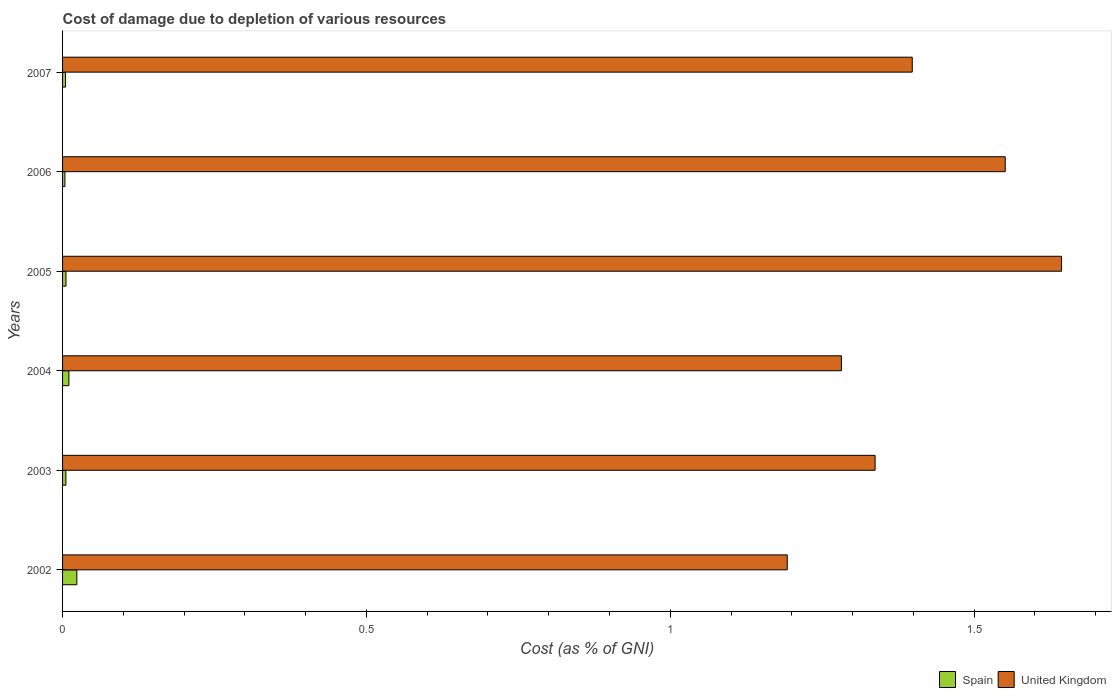How many groups of bars are there?
Your answer should be very brief. 6. Are the number of bars per tick equal to the number of legend labels?
Provide a succinct answer. Yes. How many bars are there on the 6th tick from the top?
Your answer should be very brief. 2. How many bars are there on the 2nd tick from the bottom?
Ensure brevity in your answer.  2. What is the cost of damage caused due to the depletion of various resources in United Kingdom in 2006?
Make the answer very short. 1.55. Across all years, what is the maximum cost of damage caused due to the depletion of various resources in Spain?
Your answer should be compact. 0.02. Across all years, what is the minimum cost of damage caused due to the depletion of various resources in United Kingdom?
Keep it short and to the point. 1.19. What is the total cost of damage caused due to the depletion of various resources in United Kingdom in the graph?
Your answer should be very brief. 8.4. What is the difference between the cost of damage caused due to the depletion of various resources in United Kingdom in 2005 and that in 2006?
Your answer should be compact. 0.09. What is the difference between the cost of damage caused due to the depletion of various resources in United Kingdom in 2003 and the cost of damage caused due to the depletion of various resources in Spain in 2002?
Your answer should be very brief. 1.31. What is the average cost of damage caused due to the depletion of various resources in Spain per year?
Your answer should be very brief. 0.01. In the year 2002, what is the difference between the cost of damage caused due to the depletion of various resources in United Kingdom and cost of damage caused due to the depletion of various resources in Spain?
Your answer should be very brief. 1.17. In how many years, is the cost of damage caused due to the depletion of various resources in United Kingdom greater than 1.6 %?
Offer a very short reply. 1. What is the ratio of the cost of damage caused due to the depletion of various resources in Spain in 2002 to that in 2003?
Your answer should be very brief. 4.27. Is the difference between the cost of damage caused due to the depletion of various resources in United Kingdom in 2002 and 2003 greater than the difference between the cost of damage caused due to the depletion of various resources in Spain in 2002 and 2003?
Offer a terse response. No. What is the difference between the highest and the second highest cost of damage caused due to the depletion of various resources in Spain?
Your answer should be compact. 0.01. What is the difference between the highest and the lowest cost of damage caused due to the depletion of various resources in Spain?
Offer a terse response. 0.02. Is the sum of the cost of damage caused due to the depletion of various resources in Spain in 2002 and 2005 greater than the maximum cost of damage caused due to the depletion of various resources in United Kingdom across all years?
Provide a succinct answer. No. What does the 2nd bar from the top in 2006 represents?
Your response must be concise. Spain. What does the 2nd bar from the bottom in 2002 represents?
Ensure brevity in your answer.  United Kingdom. How many bars are there?
Keep it short and to the point. 12. Does the graph contain grids?
Offer a terse response. No. Where does the legend appear in the graph?
Provide a succinct answer. Bottom right. How many legend labels are there?
Offer a terse response. 2. What is the title of the graph?
Ensure brevity in your answer.  Cost of damage due to depletion of various resources. Does "Bahamas" appear as one of the legend labels in the graph?
Provide a short and direct response. No. What is the label or title of the X-axis?
Your answer should be compact. Cost (as % of GNI). What is the label or title of the Y-axis?
Provide a succinct answer. Years. What is the Cost (as % of GNI) in Spain in 2002?
Ensure brevity in your answer.  0.02. What is the Cost (as % of GNI) of United Kingdom in 2002?
Make the answer very short. 1.19. What is the Cost (as % of GNI) of Spain in 2003?
Make the answer very short. 0.01. What is the Cost (as % of GNI) of United Kingdom in 2003?
Ensure brevity in your answer.  1.34. What is the Cost (as % of GNI) of Spain in 2004?
Give a very brief answer. 0.01. What is the Cost (as % of GNI) in United Kingdom in 2004?
Give a very brief answer. 1.28. What is the Cost (as % of GNI) in Spain in 2005?
Ensure brevity in your answer.  0.01. What is the Cost (as % of GNI) in United Kingdom in 2005?
Ensure brevity in your answer.  1.64. What is the Cost (as % of GNI) of Spain in 2006?
Your response must be concise. 0. What is the Cost (as % of GNI) of United Kingdom in 2006?
Give a very brief answer. 1.55. What is the Cost (as % of GNI) of Spain in 2007?
Make the answer very short. 0. What is the Cost (as % of GNI) of United Kingdom in 2007?
Keep it short and to the point. 1.4. Across all years, what is the maximum Cost (as % of GNI) of Spain?
Your answer should be very brief. 0.02. Across all years, what is the maximum Cost (as % of GNI) in United Kingdom?
Your answer should be compact. 1.64. Across all years, what is the minimum Cost (as % of GNI) in Spain?
Keep it short and to the point. 0. Across all years, what is the minimum Cost (as % of GNI) in United Kingdom?
Give a very brief answer. 1.19. What is the total Cost (as % of GNI) of Spain in the graph?
Offer a very short reply. 0.05. What is the total Cost (as % of GNI) in United Kingdom in the graph?
Keep it short and to the point. 8.4. What is the difference between the Cost (as % of GNI) in Spain in 2002 and that in 2003?
Your response must be concise. 0.02. What is the difference between the Cost (as % of GNI) in United Kingdom in 2002 and that in 2003?
Offer a very short reply. -0.14. What is the difference between the Cost (as % of GNI) of Spain in 2002 and that in 2004?
Your answer should be compact. 0.01. What is the difference between the Cost (as % of GNI) in United Kingdom in 2002 and that in 2004?
Provide a succinct answer. -0.09. What is the difference between the Cost (as % of GNI) in Spain in 2002 and that in 2005?
Give a very brief answer. 0.02. What is the difference between the Cost (as % of GNI) of United Kingdom in 2002 and that in 2005?
Your response must be concise. -0.45. What is the difference between the Cost (as % of GNI) of Spain in 2002 and that in 2006?
Provide a succinct answer. 0.02. What is the difference between the Cost (as % of GNI) in United Kingdom in 2002 and that in 2006?
Your answer should be compact. -0.36. What is the difference between the Cost (as % of GNI) of Spain in 2002 and that in 2007?
Give a very brief answer. 0.02. What is the difference between the Cost (as % of GNI) of United Kingdom in 2002 and that in 2007?
Your answer should be compact. -0.21. What is the difference between the Cost (as % of GNI) of Spain in 2003 and that in 2004?
Keep it short and to the point. -0. What is the difference between the Cost (as % of GNI) of United Kingdom in 2003 and that in 2004?
Provide a short and direct response. 0.06. What is the difference between the Cost (as % of GNI) in Spain in 2003 and that in 2005?
Your response must be concise. -0. What is the difference between the Cost (as % of GNI) of United Kingdom in 2003 and that in 2005?
Give a very brief answer. -0.31. What is the difference between the Cost (as % of GNI) in Spain in 2003 and that in 2006?
Provide a short and direct response. 0. What is the difference between the Cost (as % of GNI) in United Kingdom in 2003 and that in 2006?
Provide a short and direct response. -0.21. What is the difference between the Cost (as % of GNI) of Spain in 2003 and that in 2007?
Offer a very short reply. 0. What is the difference between the Cost (as % of GNI) of United Kingdom in 2003 and that in 2007?
Your answer should be compact. -0.06. What is the difference between the Cost (as % of GNI) in Spain in 2004 and that in 2005?
Ensure brevity in your answer.  0. What is the difference between the Cost (as % of GNI) in United Kingdom in 2004 and that in 2005?
Make the answer very short. -0.36. What is the difference between the Cost (as % of GNI) of Spain in 2004 and that in 2006?
Your answer should be very brief. 0.01. What is the difference between the Cost (as % of GNI) of United Kingdom in 2004 and that in 2006?
Your answer should be compact. -0.27. What is the difference between the Cost (as % of GNI) of Spain in 2004 and that in 2007?
Your answer should be compact. 0.01. What is the difference between the Cost (as % of GNI) in United Kingdom in 2004 and that in 2007?
Offer a terse response. -0.12. What is the difference between the Cost (as % of GNI) of Spain in 2005 and that in 2006?
Your answer should be very brief. 0. What is the difference between the Cost (as % of GNI) in United Kingdom in 2005 and that in 2006?
Your answer should be very brief. 0.09. What is the difference between the Cost (as % of GNI) in Spain in 2005 and that in 2007?
Provide a short and direct response. 0. What is the difference between the Cost (as % of GNI) in United Kingdom in 2005 and that in 2007?
Ensure brevity in your answer.  0.25. What is the difference between the Cost (as % of GNI) of Spain in 2006 and that in 2007?
Provide a short and direct response. -0. What is the difference between the Cost (as % of GNI) in United Kingdom in 2006 and that in 2007?
Make the answer very short. 0.15. What is the difference between the Cost (as % of GNI) of Spain in 2002 and the Cost (as % of GNI) of United Kingdom in 2003?
Ensure brevity in your answer.  -1.31. What is the difference between the Cost (as % of GNI) of Spain in 2002 and the Cost (as % of GNI) of United Kingdom in 2004?
Ensure brevity in your answer.  -1.26. What is the difference between the Cost (as % of GNI) of Spain in 2002 and the Cost (as % of GNI) of United Kingdom in 2005?
Provide a succinct answer. -1.62. What is the difference between the Cost (as % of GNI) of Spain in 2002 and the Cost (as % of GNI) of United Kingdom in 2006?
Your answer should be very brief. -1.53. What is the difference between the Cost (as % of GNI) in Spain in 2002 and the Cost (as % of GNI) in United Kingdom in 2007?
Your answer should be compact. -1.37. What is the difference between the Cost (as % of GNI) of Spain in 2003 and the Cost (as % of GNI) of United Kingdom in 2004?
Ensure brevity in your answer.  -1.28. What is the difference between the Cost (as % of GNI) in Spain in 2003 and the Cost (as % of GNI) in United Kingdom in 2005?
Offer a terse response. -1.64. What is the difference between the Cost (as % of GNI) of Spain in 2003 and the Cost (as % of GNI) of United Kingdom in 2006?
Offer a terse response. -1.55. What is the difference between the Cost (as % of GNI) in Spain in 2003 and the Cost (as % of GNI) in United Kingdom in 2007?
Your response must be concise. -1.39. What is the difference between the Cost (as % of GNI) in Spain in 2004 and the Cost (as % of GNI) in United Kingdom in 2005?
Your response must be concise. -1.63. What is the difference between the Cost (as % of GNI) of Spain in 2004 and the Cost (as % of GNI) of United Kingdom in 2006?
Offer a terse response. -1.54. What is the difference between the Cost (as % of GNI) of Spain in 2004 and the Cost (as % of GNI) of United Kingdom in 2007?
Offer a very short reply. -1.39. What is the difference between the Cost (as % of GNI) in Spain in 2005 and the Cost (as % of GNI) in United Kingdom in 2006?
Ensure brevity in your answer.  -1.55. What is the difference between the Cost (as % of GNI) of Spain in 2005 and the Cost (as % of GNI) of United Kingdom in 2007?
Ensure brevity in your answer.  -1.39. What is the difference between the Cost (as % of GNI) in Spain in 2006 and the Cost (as % of GNI) in United Kingdom in 2007?
Your answer should be very brief. -1.39. What is the average Cost (as % of GNI) in Spain per year?
Offer a terse response. 0.01. What is the average Cost (as % of GNI) in United Kingdom per year?
Offer a terse response. 1.4. In the year 2002, what is the difference between the Cost (as % of GNI) of Spain and Cost (as % of GNI) of United Kingdom?
Give a very brief answer. -1.17. In the year 2003, what is the difference between the Cost (as % of GNI) of Spain and Cost (as % of GNI) of United Kingdom?
Provide a succinct answer. -1.33. In the year 2004, what is the difference between the Cost (as % of GNI) in Spain and Cost (as % of GNI) in United Kingdom?
Make the answer very short. -1.27. In the year 2005, what is the difference between the Cost (as % of GNI) in Spain and Cost (as % of GNI) in United Kingdom?
Offer a very short reply. -1.64. In the year 2006, what is the difference between the Cost (as % of GNI) in Spain and Cost (as % of GNI) in United Kingdom?
Ensure brevity in your answer.  -1.55. In the year 2007, what is the difference between the Cost (as % of GNI) in Spain and Cost (as % of GNI) in United Kingdom?
Make the answer very short. -1.39. What is the ratio of the Cost (as % of GNI) of Spain in 2002 to that in 2003?
Offer a very short reply. 4.27. What is the ratio of the Cost (as % of GNI) in United Kingdom in 2002 to that in 2003?
Your response must be concise. 0.89. What is the ratio of the Cost (as % of GNI) of Spain in 2002 to that in 2004?
Make the answer very short. 2.25. What is the ratio of the Cost (as % of GNI) in United Kingdom in 2002 to that in 2004?
Offer a very short reply. 0.93. What is the ratio of the Cost (as % of GNI) in Spain in 2002 to that in 2005?
Offer a terse response. 4.17. What is the ratio of the Cost (as % of GNI) in United Kingdom in 2002 to that in 2005?
Your response must be concise. 0.73. What is the ratio of the Cost (as % of GNI) in Spain in 2002 to that in 2006?
Give a very brief answer. 6.11. What is the ratio of the Cost (as % of GNI) of United Kingdom in 2002 to that in 2006?
Your answer should be compact. 0.77. What is the ratio of the Cost (as % of GNI) in Spain in 2002 to that in 2007?
Your answer should be compact. 4.77. What is the ratio of the Cost (as % of GNI) of United Kingdom in 2002 to that in 2007?
Your answer should be very brief. 0.85. What is the ratio of the Cost (as % of GNI) in Spain in 2003 to that in 2004?
Your answer should be very brief. 0.53. What is the ratio of the Cost (as % of GNI) in United Kingdom in 2003 to that in 2004?
Give a very brief answer. 1.04. What is the ratio of the Cost (as % of GNI) of Spain in 2003 to that in 2005?
Keep it short and to the point. 0.98. What is the ratio of the Cost (as % of GNI) in United Kingdom in 2003 to that in 2005?
Your answer should be very brief. 0.81. What is the ratio of the Cost (as % of GNI) of Spain in 2003 to that in 2006?
Provide a succinct answer. 1.43. What is the ratio of the Cost (as % of GNI) of United Kingdom in 2003 to that in 2006?
Keep it short and to the point. 0.86. What is the ratio of the Cost (as % of GNI) in Spain in 2003 to that in 2007?
Make the answer very short. 1.12. What is the ratio of the Cost (as % of GNI) of United Kingdom in 2003 to that in 2007?
Keep it short and to the point. 0.96. What is the ratio of the Cost (as % of GNI) in Spain in 2004 to that in 2005?
Your answer should be compact. 1.85. What is the ratio of the Cost (as % of GNI) in United Kingdom in 2004 to that in 2005?
Your response must be concise. 0.78. What is the ratio of the Cost (as % of GNI) of Spain in 2004 to that in 2006?
Keep it short and to the point. 2.72. What is the ratio of the Cost (as % of GNI) of United Kingdom in 2004 to that in 2006?
Offer a terse response. 0.83. What is the ratio of the Cost (as % of GNI) in Spain in 2004 to that in 2007?
Offer a very short reply. 2.12. What is the ratio of the Cost (as % of GNI) in United Kingdom in 2004 to that in 2007?
Your answer should be very brief. 0.92. What is the ratio of the Cost (as % of GNI) of Spain in 2005 to that in 2006?
Your answer should be very brief. 1.47. What is the ratio of the Cost (as % of GNI) of United Kingdom in 2005 to that in 2006?
Your answer should be compact. 1.06. What is the ratio of the Cost (as % of GNI) in Spain in 2005 to that in 2007?
Ensure brevity in your answer.  1.14. What is the ratio of the Cost (as % of GNI) in United Kingdom in 2005 to that in 2007?
Provide a succinct answer. 1.18. What is the ratio of the Cost (as % of GNI) of Spain in 2006 to that in 2007?
Your response must be concise. 0.78. What is the ratio of the Cost (as % of GNI) in United Kingdom in 2006 to that in 2007?
Make the answer very short. 1.11. What is the difference between the highest and the second highest Cost (as % of GNI) of Spain?
Your answer should be very brief. 0.01. What is the difference between the highest and the second highest Cost (as % of GNI) of United Kingdom?
Give a very brief answer. 0.09. What is the difference between the highest and the lowest Cost (as % of GNI) of Spain?
Make the answer very short. 0.02. What is the difference between the highest and the lowest Cost (as % of GNI) of United Kingdom?
Provide a short and direct response. 0.45. 